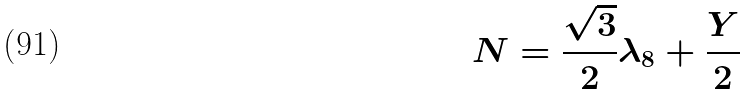Convert formula to latex. <formula><loc_0><loc_0><loc_500><loc_500>N = \frac { \sqrt { 3 } } { 2 } \lambda _ { 8 } + \frac { Y } { 2 }</formula> 